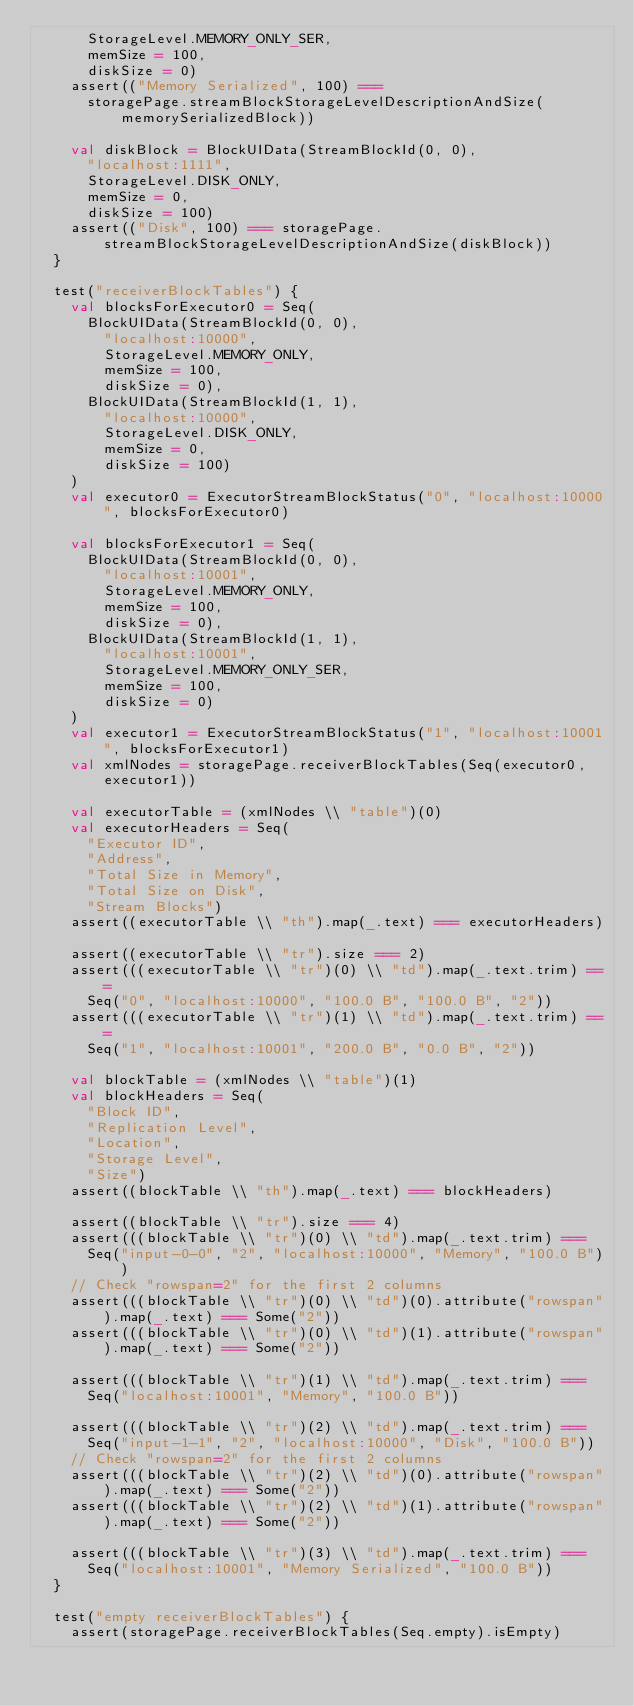<code> <loc_0><loc_0><loc_500><loc_500><_Scala_>      StorageLevel.MEMORY_ONLY_SER,
      memSize = 100,
      diskSize = 0)
    assert(("Memory Serialized", 100) ===
      storagePage.streamBlockStorageLevelDescriptionAndSize(memorySerializedBlock))

    val diskBlock = BlockUIData(StreamBlockId(0, 0),
      "localhost:1111",
      StorageLevel.DISK_ONLY,
      memSize = 0,
      diskSize = 100)
    assert(("Disk", 100) === storagePage.streamBlockStorageLevelDescriptionAndSize(diskBlock))
  }

  test("receiverBlockTables") {
    val blocksForExecutor0 = Seq(
      BlockUIData(StreamBlockId(0, 0),
        "localhost:10000",
        StorageLevel.MEMORY_ONLY,
        memSize = 100,
        diskSize = 0),
      BlockUIData(StreamBlockId(1, 1),
        "localhost:10000",
        StorageLevel.DISK_ONLY,
        memSize = 0,
        diskSize = 100)
    )
    val executor0 = ExecutorStreamBlockStatus("0", "localhost:10000", blocksForExecutor0)

    val blocksForExecutor1 = Seq(
      BlockUIData(StreamBlockId(0, 0),
        "localhost:10001",
        StorageLevel.MEMORY_ONLY,
        memSize = 100,
        diskSize = 0),
      BlockUIData(StreamBlockId(1, 1),
        "localhost:10001",
        StorageLevel.MEMORY_ONLY_SER,
        memSize = 100,
        diskSize = 0)
    )
    val executor1 = ExecutorStreamBlockStatus("1", "localhost:10001", blocksForExecutor1)
    val xmlNodes = storagePage.receiverBlockTables(Seq(executor0, executor1))

    val executorTable = (xmlNodes \\ "table")(0)
    val executorHeaders = Seq(
      "Executor ID",
      "Address",
      "Total Size in Memory",
      "Total Size on Disk",
      "Stream Blocks")
    assert((executorTable \\ "th").map(_.text) === executorHeaders)

    assert((executorTable \\ "tr").size === 2)
    assert(((executorTable \\ "tr")(0) \\ "td").map(_.text.trim) ===
      Seq("0", "localhost:10000", "100.0 B", "100.0 B", "2"))
    assert(((executorTable \\ "tr")(1) \\ "td").map(_.text.trim) ===
      Seq("1", "localhost:10001", "200.0 B", "0.0 B", "2"))

    val blockTable = (xmlNodes \\ "table")(1)
    val blockHeaders = Seq(
      "Block ID",
      "Replication Level",
      "Location",
      "Storage Level",
      "Size")
    assert((blockTable \\ "th").map(_.text) === blockHeaders)

    assert((blockTable \\ "tr").size === 4)
    assert(((blockTable \\ "tr")(0) \\ "td").map(_.text.trim) ===
      Seq("input-0-0", "2", "localhost:10000", "Memory", "100.0 B"))
    // Check "rowspan=2" for the first 2 columns
    assert(((blockTable \\ "tr")(0) \\ "td")(0).attribute("rowspan").map(_.text) === Some("2"))
    assert(((blockTable \\ "tr")(0) \\ "td")(1).attribute("rowspan").map(_.text) === Some("2"))

    assert(((blockTable \\ "tr")(1) \\ "td").map(_.text.trim) ===
      Seq("localhost:10001", "Memory", "100.0 B"))

    assert(((blockTable \\ "tr")(2) \\ "td").map(_.text.trim) ===
      Seq("input-1-1", "2", "localhost:10000", "Disk", "100.0 B"))
    // Check "rowspan=2" for the first 2 columns
    assert(((blockTable \\ "tr")(2) \\ "td")(0).attribute("rowspan").map(_.text) === Some("2"))
    assert(((blockTable \\ "tr")(2) \\ "td")(1).attribute("rowspan").map(_.text) === Some("2"))

    assert(((blockTable \\ "tr")(3) \\ "td").map(_.text.trim) ===
      Seq("localhost:10001", "Memory Serialized", "100.0 B"))
  }

  test("empty receiverBlockTables") {
    assert(storagePage.receiverBlockTables(Seq.empty).isEmpty)</code> 